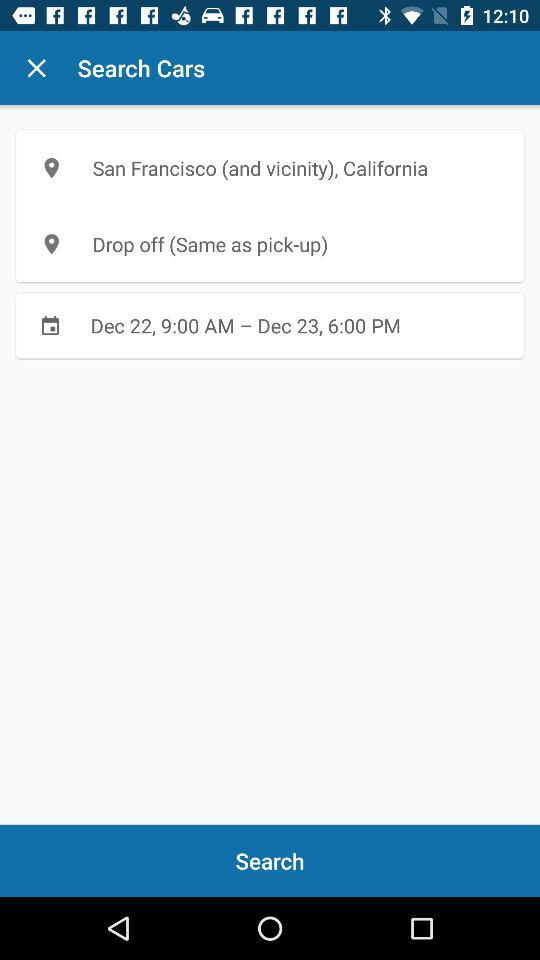What is the mentioned interval? The mentioned interval is from December 22, 9:00 AM to December 23, 6:00 PM. 